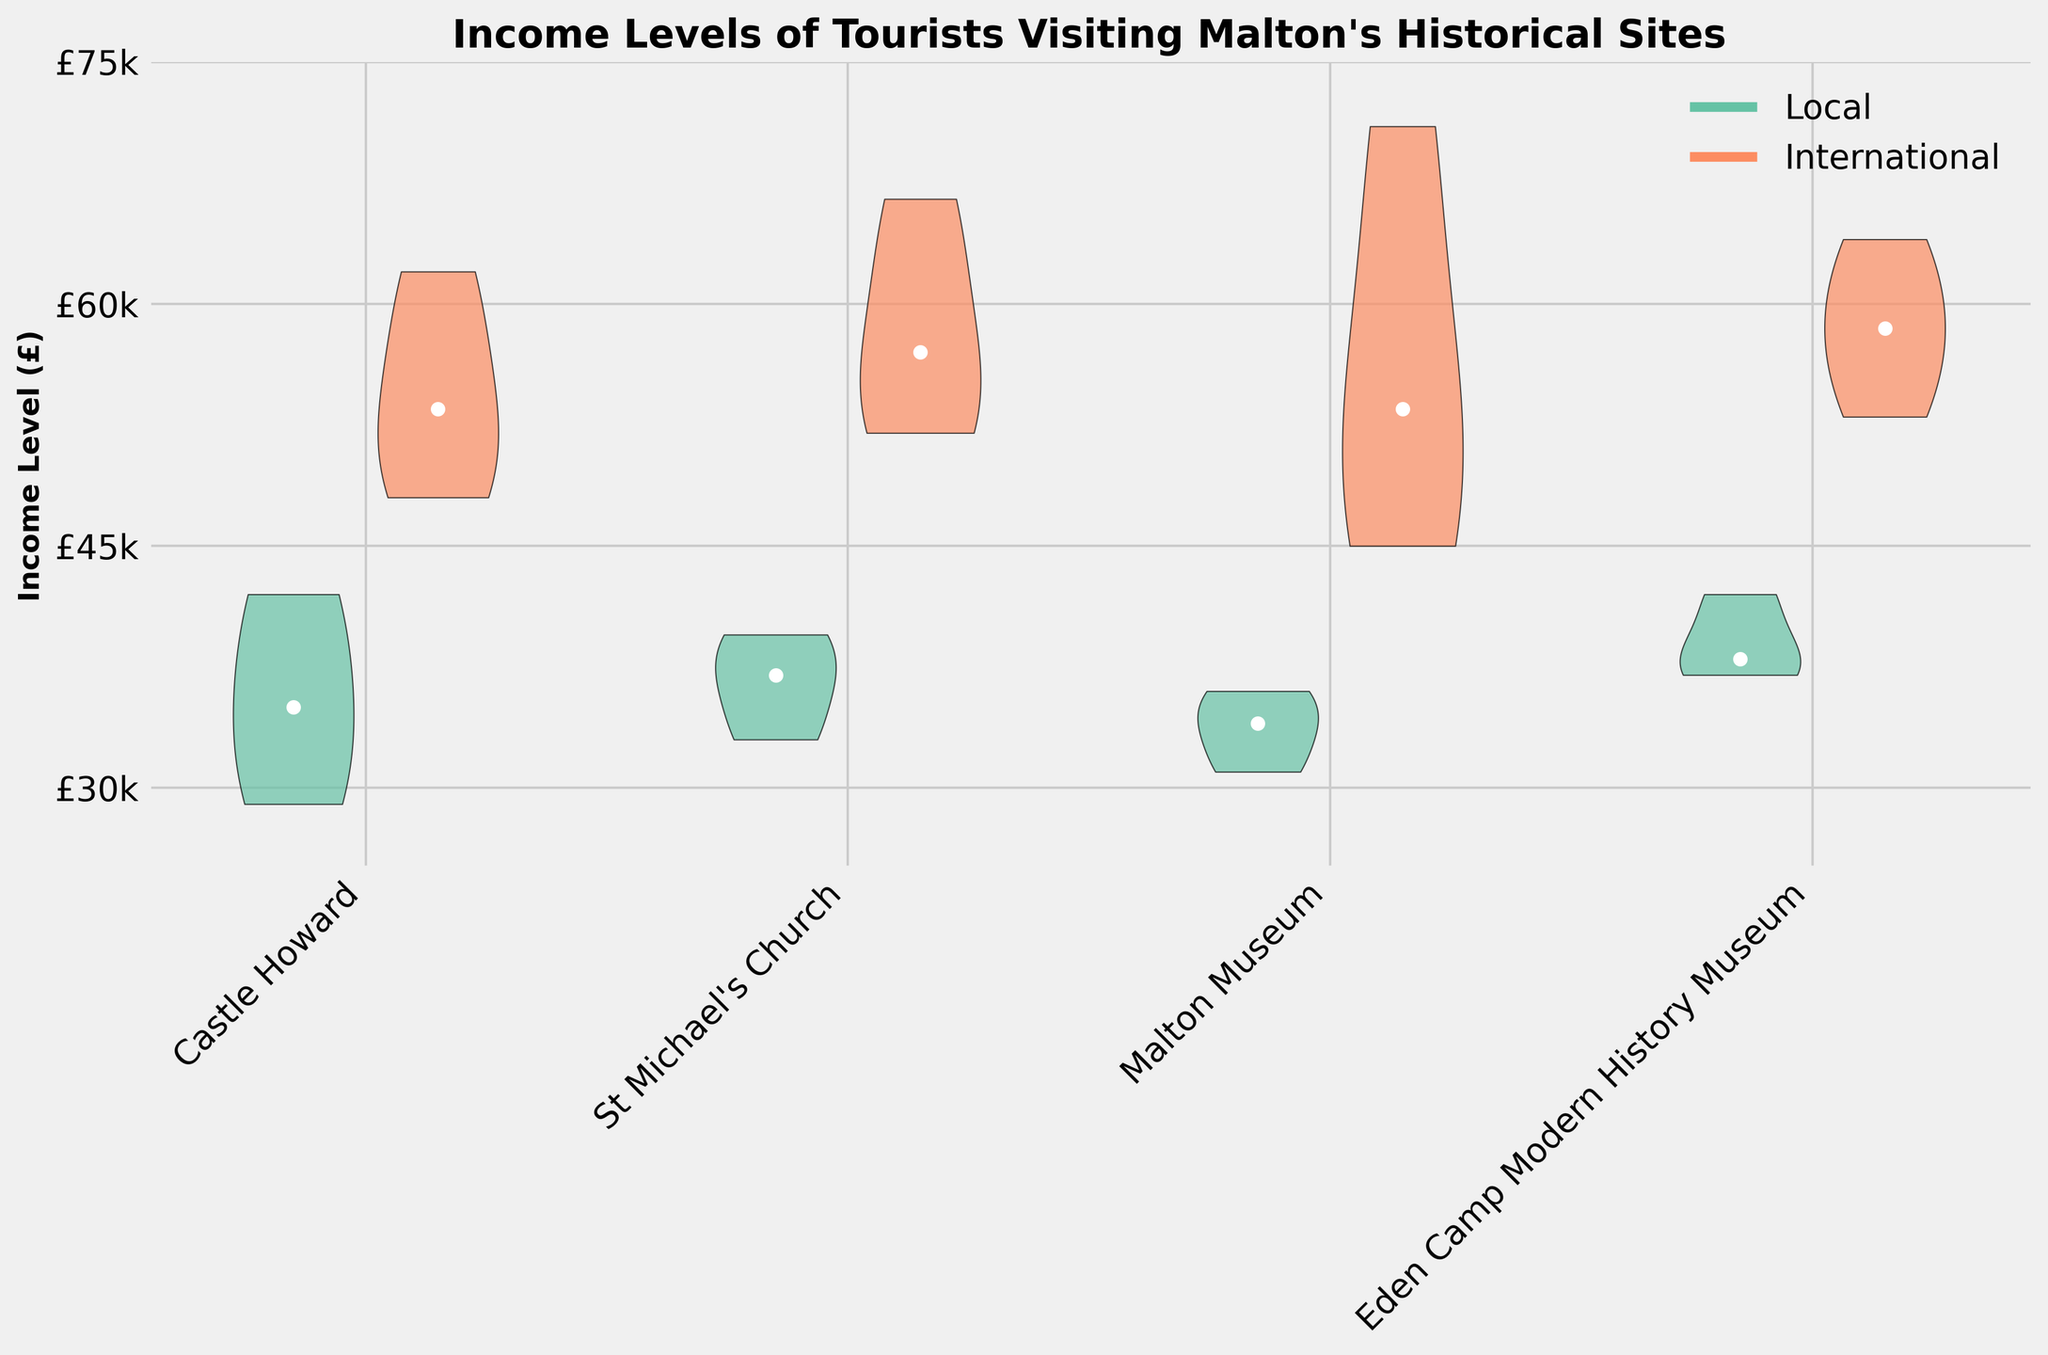What is the title of the figure? The title is located at the top center of the plot and provides a summary of what the chart represents.
Answer: Income Levels of Tourists Visiting Malton's Historical Sites Which visitor type has the higher median income for Castle Howard? The median income for each visitor type is marked by a white dot on the split violins. For Castle Howard, the International visitors' median income is higher than that of the Local visitors.
Answer: International visitors What is the range of income levels for local visitors at St Michael's Church? For local visitors at St Michael's Church, the violin plot stretches from roughly £30,000 to £40,000, indicating the range.
Answer: £30,000 to £40,000 Compare the median incomes of international visitors at Malton Museum and Eden Camp Modern History Museum. Which is higher? By observing the white dots on the violin plots for international visitors, Malton Museum's median is slightly higher compared to Eden Camp Modern History Museum.
Answer: Malton Museum What is the difference between the highest income level of international visitors at Malton Museum and the highest income level of local visitors at Eden Camp Modern History Museum? The highest income level for international visitors at Malton Museum is around £71,000, and for local visitors at Eden Camp Modern History Museum it is around £42,000. The difference is £71,000 - £42,000.
Answer: £29,000 Which historical site has the widest range of incomes for local visitors? The width of the violin plots represent the spread of income levels. Castle Howard's local visitors have a notably wider range compared to other sites.
Answer: Castle Howard Are there more sites where local visitors have a higher median income than international visitors, or the opposite? By checking each site, for all sites (Castle Howard, St Michael's Church, Malton Museum, and Eden Camp Modern History Museum), the median income for international visitors is higher than that of local visitors as indicated by the white dots.
Answer: International visitors have higher median incomes How does the overall income level (including both local and international visitors) at Malton Museum compare to that at St Michael's Church? To compare the overall income levels, observe the full lengths of the violin plots for both local and international visitors at each site. At Malton Museum, both local and international visitors tend to show higher income levels compared to St Michael's Church.
Answer: Malton Museum has higher overall income levels What is the average income level for international visitors at St Michael's Church? Adding up the income levels for international visitors at St Michael's Church (66500, 54000, 60000, 52000) gives 232,500. Dividing by the number of entries (4) gives the average income.
Answer: £58,125 